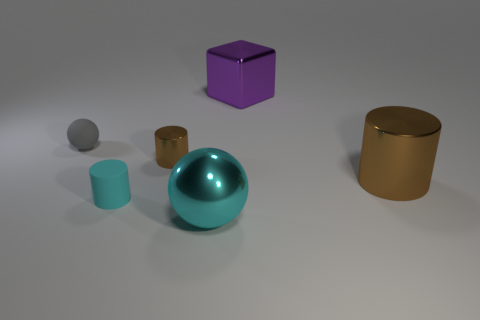How many objects are either matte things in front of the big brown metallic cylinder or tiny rubber spheres? There are two matte objects in front of the big brown metallic cylinder, which are the small teal-colored cylinder and the large teal-colored sphere. As for tiny rubber spheres, there is one gray sphere present in the image, making the total count of objects fitting the description three. 